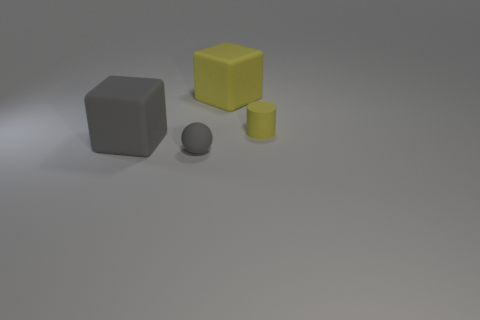Is the number of cylinders that are in front of the yellow matte cylinder the same as the number of purple rubber blocks?
Give a very brief answer. Yes. The gray object that is to the left of the small matte object in front of the tiny rubber thing that is behind the sphere is made of what material?
Offer a terse response. Rubber. The rubber cube that is left of the yellow block is what color?
Make the answer very short. Gray. Are there any other things that are the same shape as the tiny yellow thing?
Your answer should be compact. No. How big is the rubber thing that is to the right of the cube to the right of the gray block?
Provide a succinct answer. Small. Are there an equal number of gray rubber balls behind the small gray thing and small balls behind the yellow rubber cube?
Give a very brief answer. Yes. Are there any other things that have the same size as the gray ball?
Make the answer very short. Yes. What is the color of the small cylinder that is made of the same material as the small ball?
Your response must be concise. Yellow. Do the gray sphere and the large thing that is in front of the yellow cube have the same material?
Keep it short and to the point. Yes. What is the color of the object that is both behind the tiny sphere and left of the large yellow thing?
Offer a terse response. Gray. 